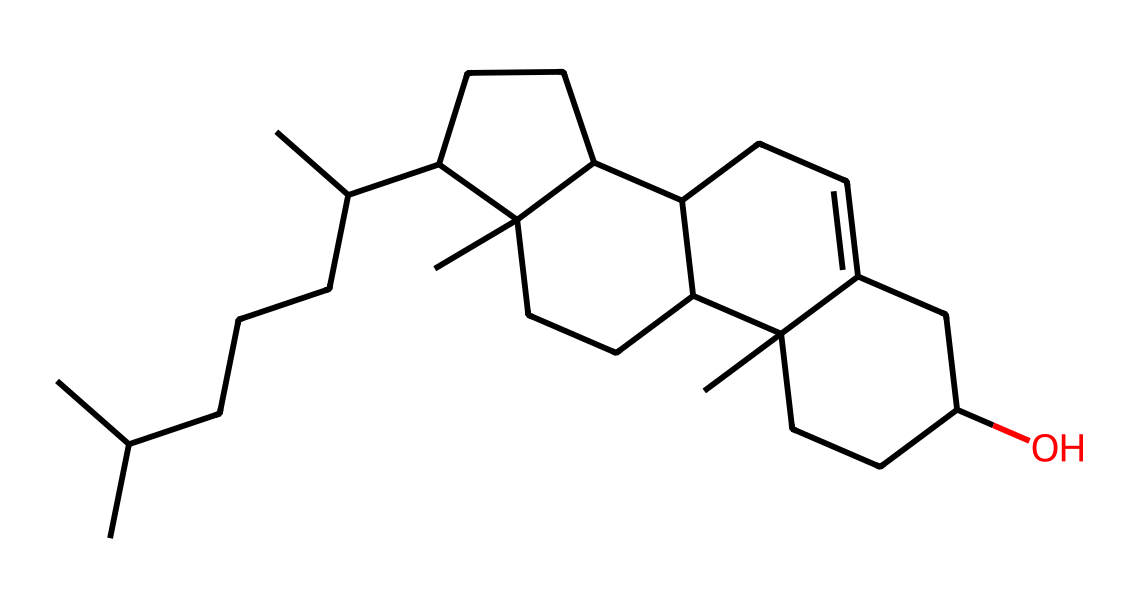What is the primary functional group present in cholesterol? The chemical structure of cholesterol reveals that it contains a hydroxyl group (-OH) which is characteristic of alcohols. This functional group is visible in the structure where the oxygen atom is bonded to a carbon atom.
Answer: hydroxyl How many carbon atoms are present in cholesterol? By analyzing the SMILES representation, we can count a total of 27 carbon atoms in the structure. Each "C" in the SMILES represents a carbon atom.
Answer: 27 What is the number of double bonds in the cholesterol structure? The SMILES notation indicates a single double bond in the cyclohexene ring (C=C), which is a feature of the steroid framework. Counting from the visual representation confirms this observation.
Answer: 1 What type of lipid class does cholesterol belong to? Cholesterol is recognized as a sterol, a specific category within sterols which possess a hydrocarbon skeleton and a hydroxyl group.
Answer: sterol How does the structure of cholesterol relate to its role in cell membranes? The structure's amphipathic nature, with a hydrophilic hydroxyl group and a hydrophobic steroid ring, allows cholesterol to fit between phospholipid bilayers in cell membranes, providing stability and fluidity.
Answer: amphipathic What property of cholesterol is indicated by its large hydrocarbon tail? The extensive hydrocarbon tail indicated in the structure suggests high hydrophobicity, enabling cholesterol to interact favorably within lipid environments.
Answer: hydrophobicity 